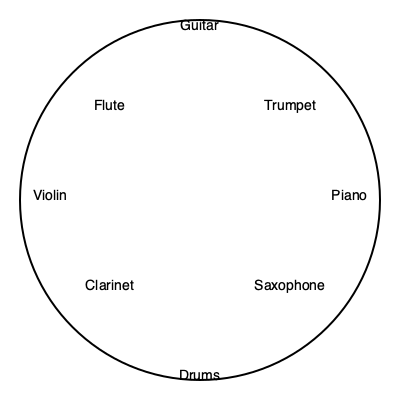If you want to arrange 8 musical instruments in a circular formation for a family sing-along, with the guitar directly across from the drums, and the piano to the right of the drums, in which position should you place the violin? To solve this problem, let's follow these steps:

1. Identify the fixed positions:
   - Guitar is directly across from the drums
   - Piano is to the right of the drums

2. Visualize the circle divided into 8 equal sections, like a clock face.

3. Place the instruments:
   - Put the drums at the 6 o'clock position
   - The guitar will be at 12 o'clock (opposite the drums)
   - The piano will be at 7 o'clock (to the right of the drums)

4. Now, we need to find the position directly opposite the piano:
   - The opposite position to 7 o'clock is 1 o'clock

5. This 1 o'clock position is where the violin should be placed, as it's directly across from the piano and to the left of the guitar.

Therefore, the violin should be placed to the left of the guitar, or at the 1 o'clock position in our circular arrangement.
Answer: To the left of the guitar 